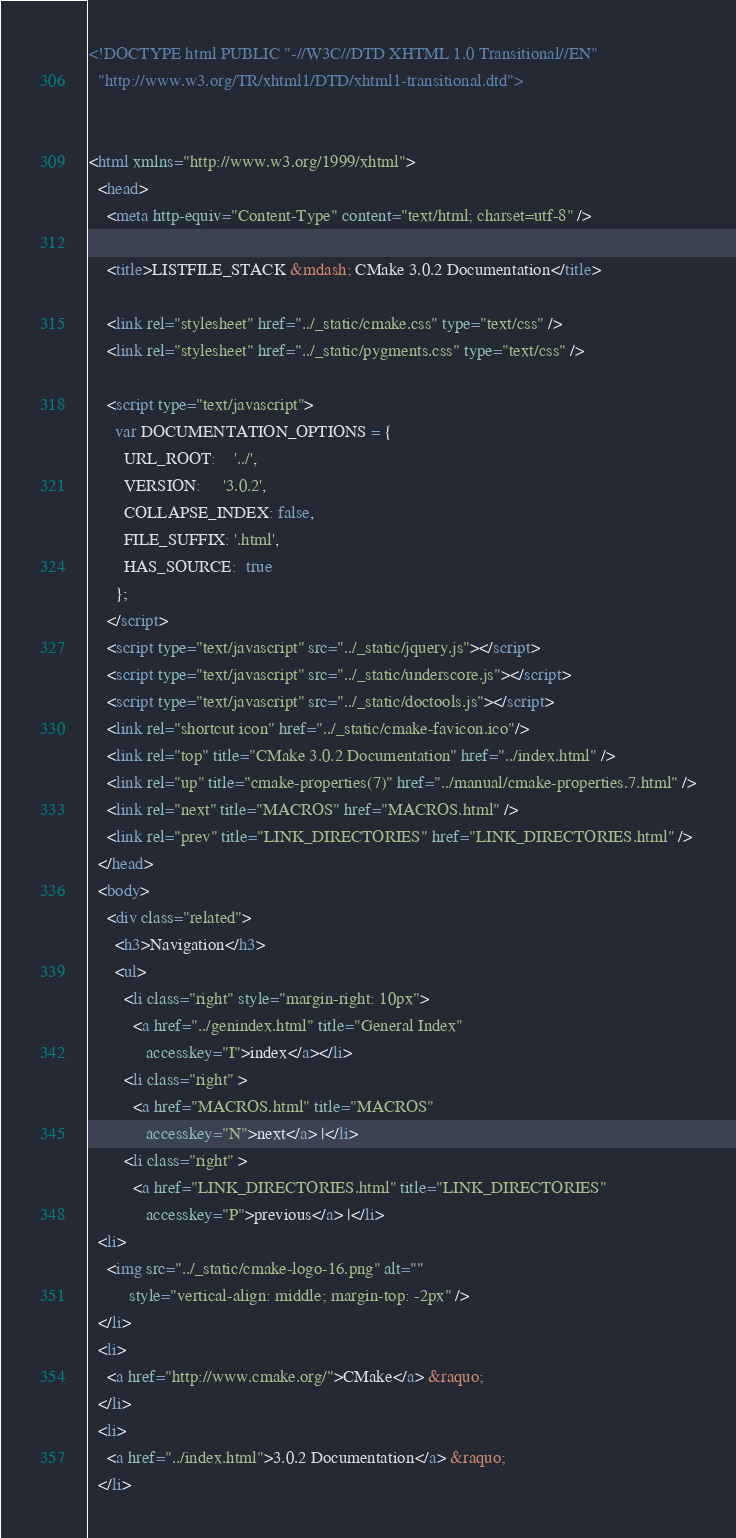Convert code to text. <code><loc_0><loc_0><loc_500><loc_500><_HTML_><!DOCTYPE html PUBLIC "-//W3C//DTD XHTML 1.0 Transitional//EN"
  "http://www.w3.org/TR/xhtml1/DTD/xhtml1-transitional.dtd">


<html xmlns="http://www.w3.org/1999/xhtml">
  <head>
    <meta http-equiv="Content-Type" content="text/html; charset=utf-8" />
    
    <title>LISTFILE_STACK &mdash; CMake 3.0.2 Documentation</title>
    
    <link rel="stylesheet" href="../_static/cmake.css" type="text/css" />
    <link rel="stylesheet" href="../_static/pygments.css" type="text/css" />
    
    <script type="text/javascript">
      var DOCUMENTATION_OPTIONS = {
        URL_ROOT:    '../',
        VERSION:     '3.0.2',
        COLLAPSE_INDEX: false,
        FILE_SUFFIX: '.html',
        HAS_SOURCE:  true
      };
    </script>
    <script type="text/javascript" src="../_static/jquery.js"></script>
    <script type="text/javascript" src="../_static/underscore.js"></script>
    <script type="text/javascript" src="../_static/doctools.js"></script>
    <link rel="shortcut icon" href="../_static/cmake-favicon.ico"/>
    <link rel="top" title="CMake 3.0.2 Documentation" href="../index.html" />
    <link rel="up" title="cmake-properties(7)" href="../manual/cmake-properties.7.html" />
    <link rel="next" title="MACROS" href="MACROS.html" />
    <link rel="prev" title="LINK_DIRECTORIES" href="LINK_DIRECTORIES.html" /> 
  </head>
  <body>
    <div class="related">
      <h3>Navigation</h3>
      <ul>
        <li class="right" style="margin-right: 10px">
          <a href="../genindex.html" title="General Index"
             accesskey="I">index</a></li>
        <li class="right" >
          <a href="MACROS.html" title="MACROS"
             accesskey="N">next</a> |</li>
        <li class="right" >
          <a href="LINK_DIRECTORIES.html" title="LINK_DIRECTORIES"
             accesskey="P">previous</a> |</li>
  <li>
    <img src="../_static/cmake-logo-16.png" alt=""
         style="vertical-align: middle; margin-top: -2px" />
  </li>
  <li>
    <a href="http://www.cmake.org/">CMake</a> &raquo;
  </li>
  <li>
    <a href="../index.html">3.0.2 Documentation</a> &raquo;
  </li>
</code> 